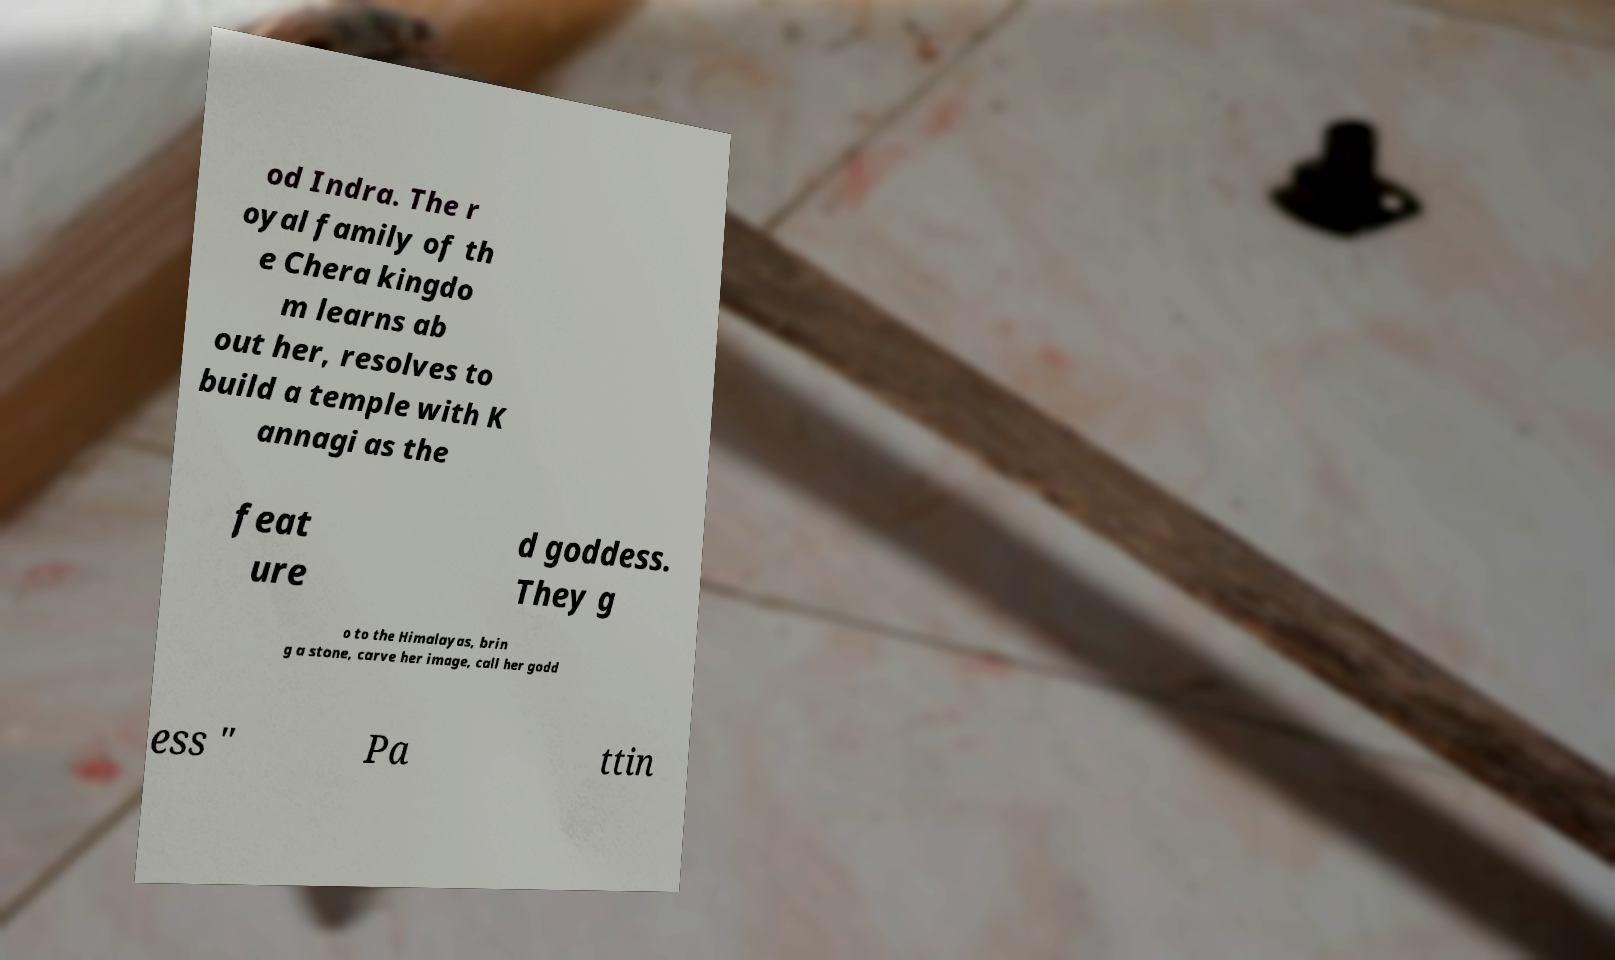Please identify and transcribe the text found in this image. od Indra. The r oyal family of th e Chera kingdo m learns ab out her, resolves to build a temple with K annagi as the feat ure d goddess. They g o to the Himalayas, brin g a stone, carve her image, call her godd ess " Pa ttin 